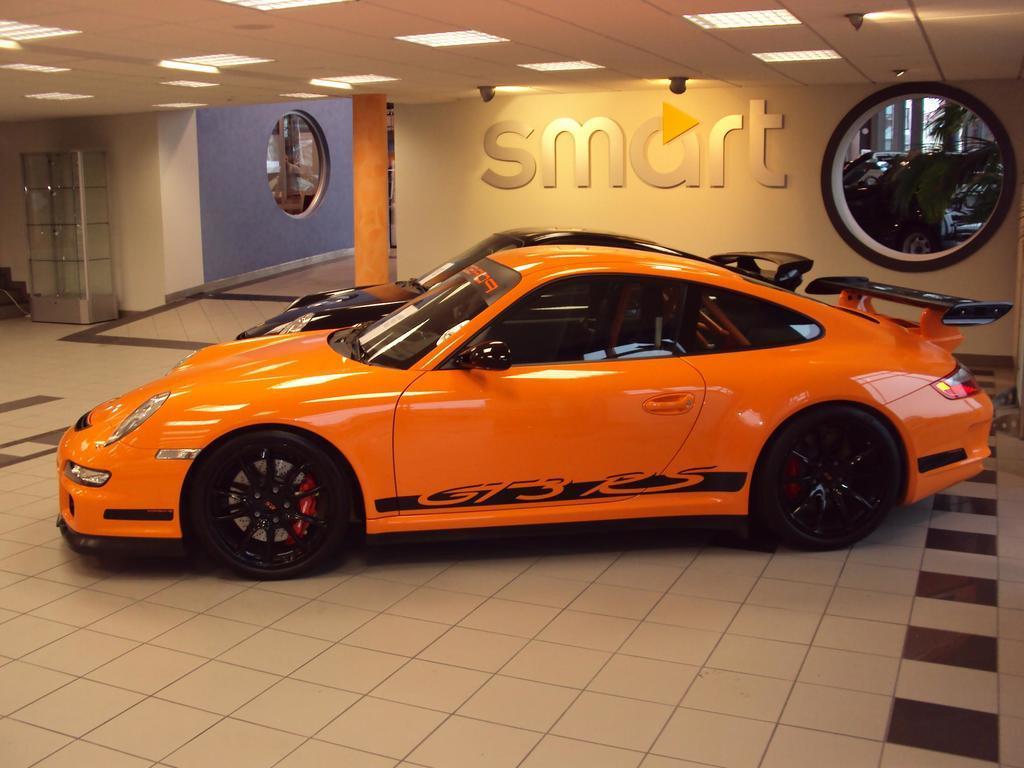Could you give a brief overview of what you see in this image? In the foreground, I can see two cars on the floor. In the background, I can see a text on a wall, glass windows, lights on a rooftop and some objects on the floor. This picture taken, maybe in a building. 